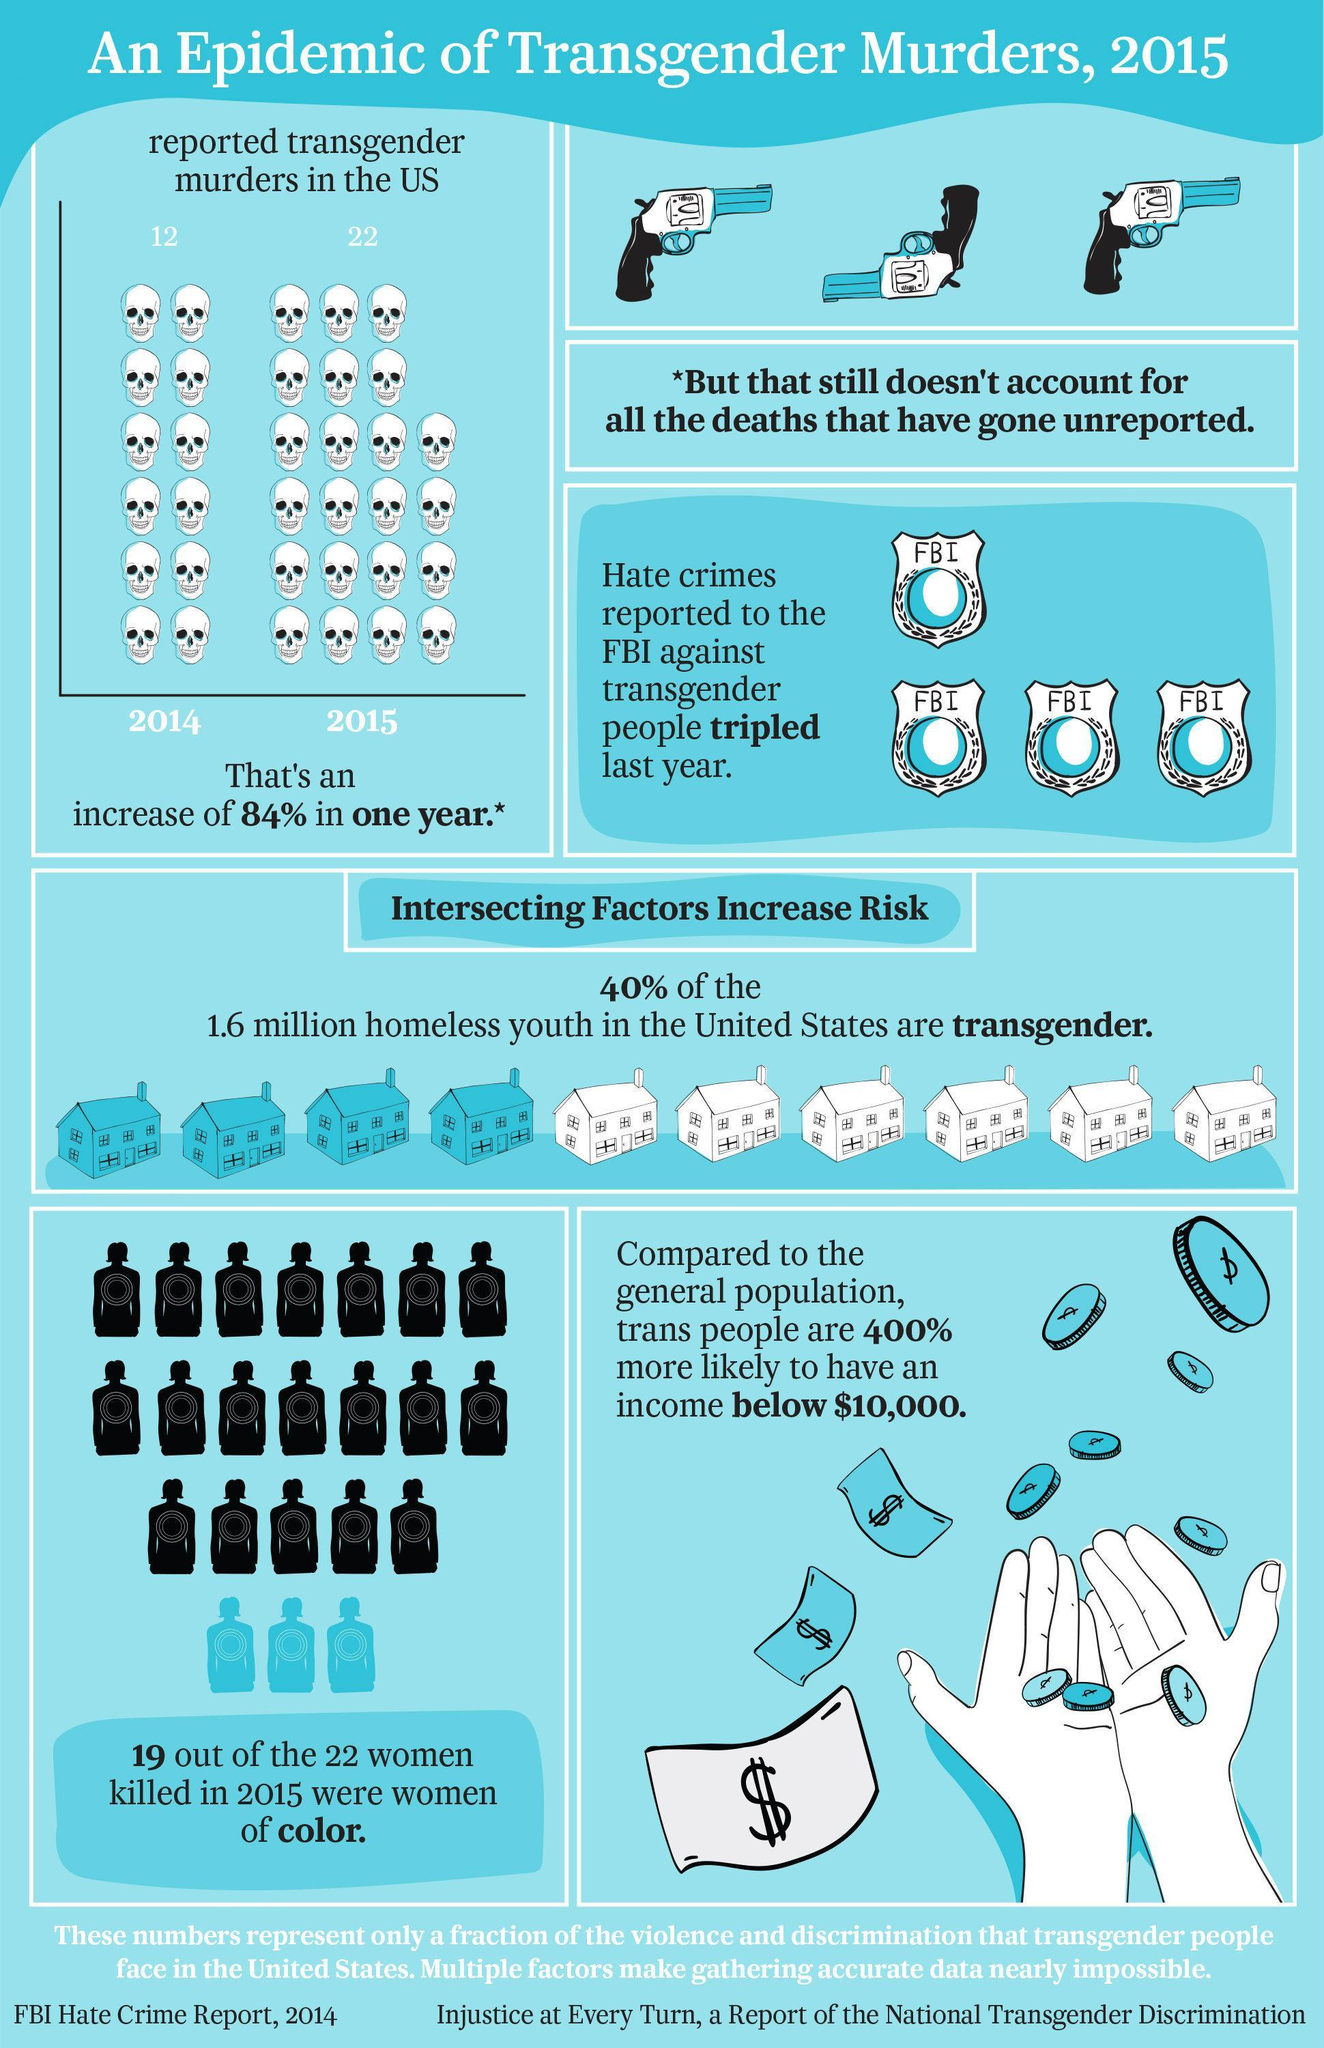What is the number of homeless transgender youth in the United States?
Answer the question with a short phrase. 640,000 How much increase did reported transgender murders in the US see from 2014 to 2015? 10 